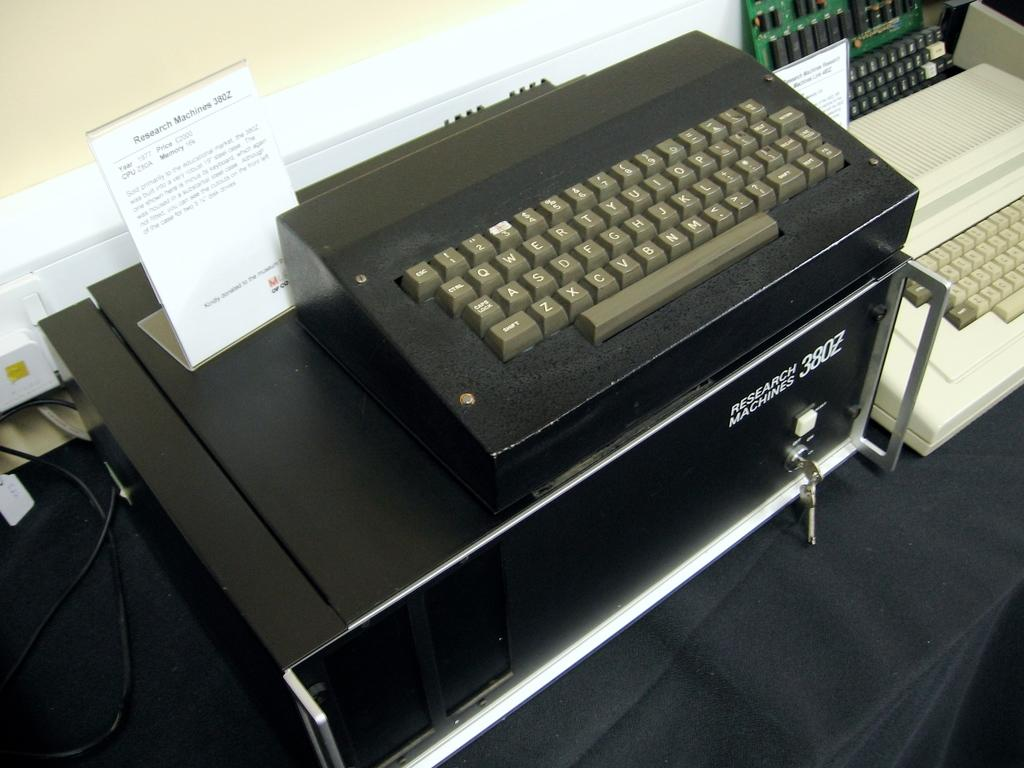<image>
Write a terse but informative summary of the picture. A keyboard that says Search Machines on it. 